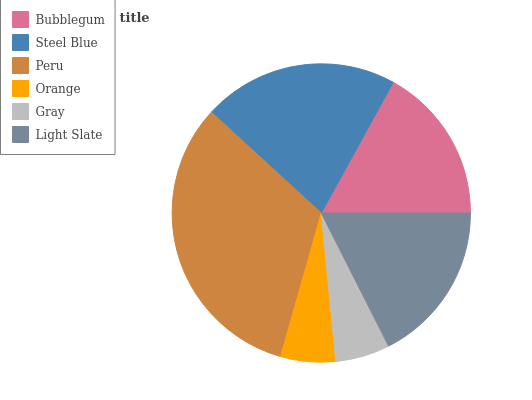Is Gray the minimum?
Answer yes or no. Yes. Is Peru the maximum?
Answer yes or no. Yes. Is Steel Blue the minimum?
Answer yes or no. No. Is Steel Blue the maximum?
Answer yes or no. No. Is Steel Blue greater than Bubblegum?
Answer yes or no. Yes. Is Bubblegum less than Steel Blue?
Answer yes or no. Yes. Is Bubblegum greater than Steel Blue?
Answer yes or no. No. Is Steel Blue less than Bubblegum?
Answer yes or no. No. Is Light Slate the high median?
Answer yes or no. Yes. Is Bubblegum the low median?
Answer yes or no. Yes. Is Orange the high median?
Answer yes or no. No. Is Steel Blue the low median?
Answer yes or no. No. 